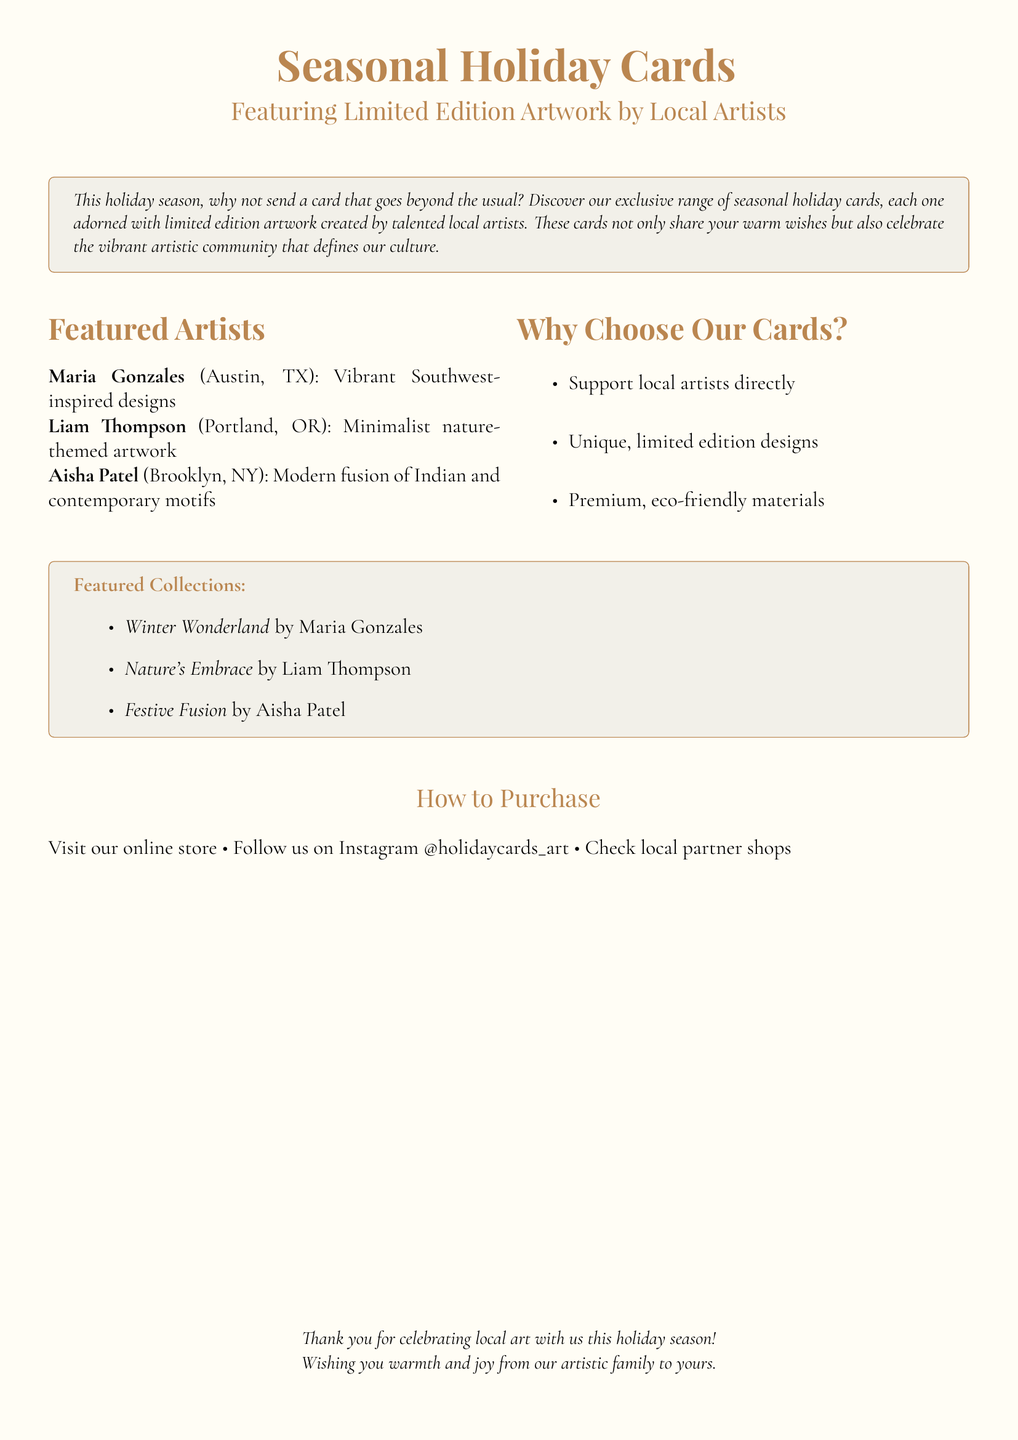What is the title of the card collection? The title of the card collection is prominently displayed at the beginning of the document.
Answer: Seasonal Holiday Cards Who is the artist from Austin, TX? The document lists various featured artists along with their locations.
Answer: Maria Gonzales What is the theme of Liam Thompson's collection? The document describes the themes corresponding to each artist's work.
Answer: Nature-themed artwork What is one benefit of choosing these cards? The document mentions specific reasons to choose these cards in a list format.
Answer: Support local artists directly How many featured collections are listed? The document has a section that showcases the different collections of holiday cards.
Answer: Three 